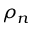<formula> <loc_0><loc_0><loc_500><loc_500>\rho _ { n }</formula> 